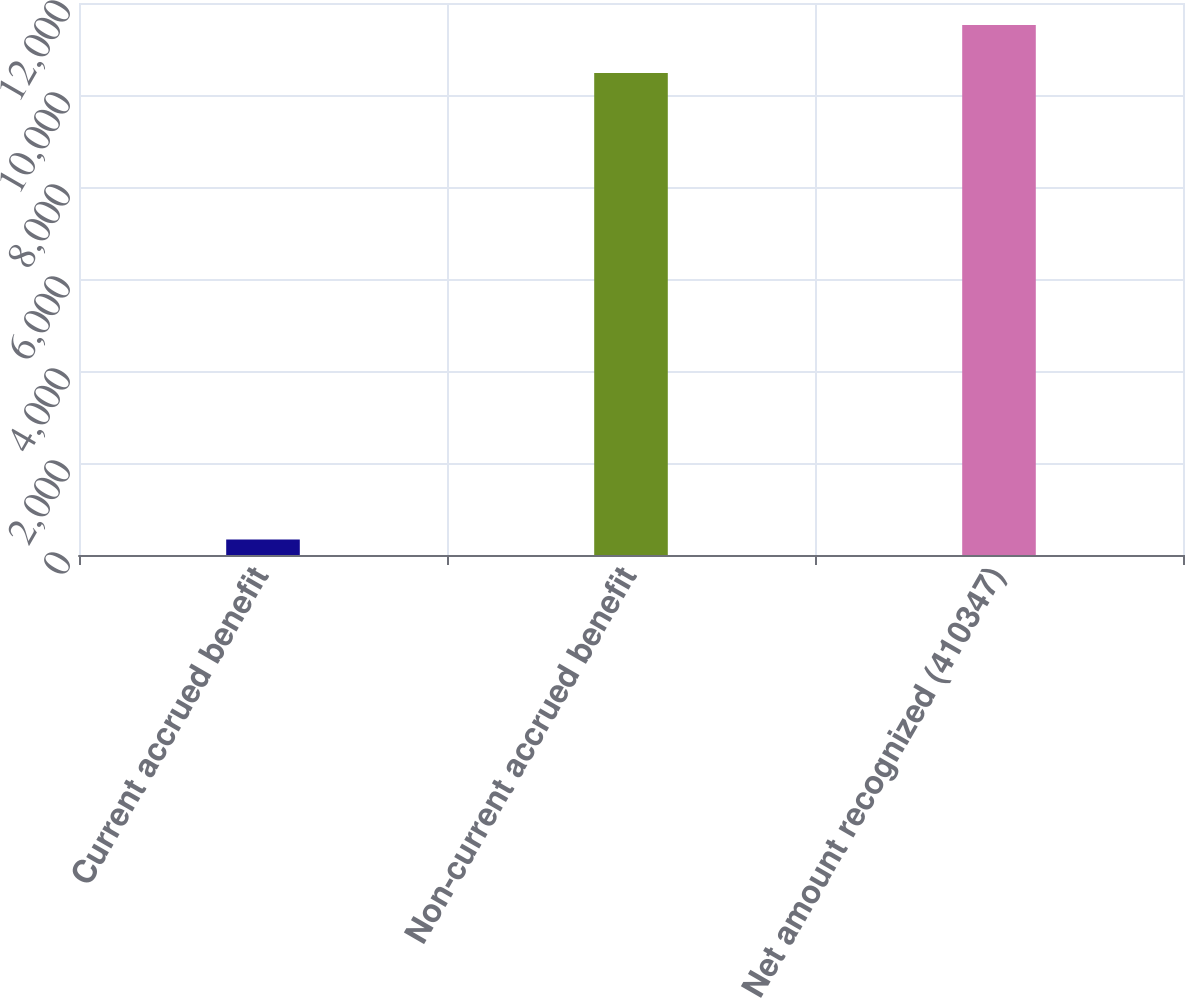<chart> <loc_0><loc_0><loc_500><loc_500><bar_chart><fcel>Current accrued benefit<fcel>Non-current accrued benefit<fcel>Net amount recognized (410347)<nl><fcel>336<fcel>10476<fcel>11523.6<nl></chart> 